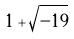Convert formula to latex. <formula><loc_0><loc_0><loc_500><loc_500>1 + \sqrt { - 1 9 }</formula> 